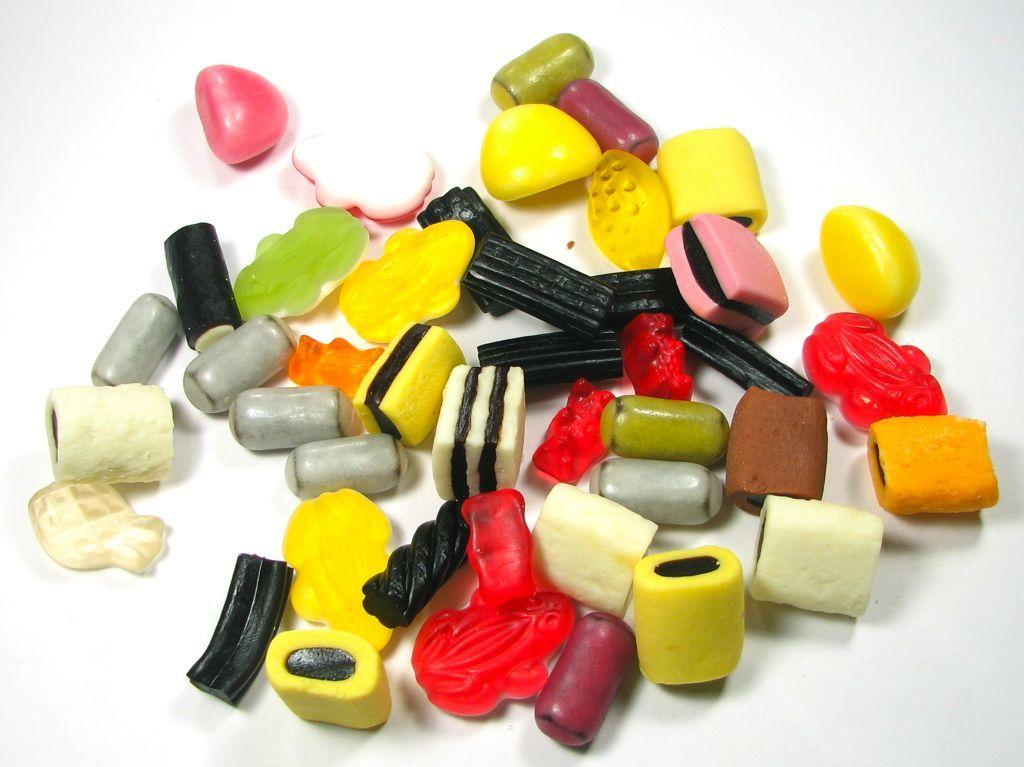What type of food can be seen in the image? There are candies in the image. What is the color of the object on which the candies are placed? The object is white. What type of picture is hanging on the wall behind the candies? There is no information about a picture hanging on the wall behind the candies, as it is not mentioned in the provided facts. 